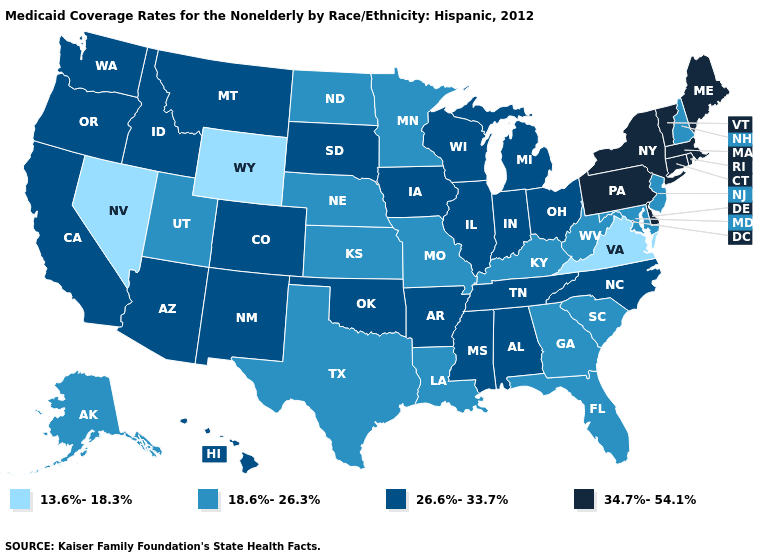What is the highest value in the USA?
Be succinct. 34.7%-54.1%. Which states have the lowest value in the West?
Concise answer only. Nevada, Wyoming. Does Minnesota have the same value as California?
Short answer required. No. Does Vermont have the highest value in the USA?
Write a very short answer. Yes. Is the legend a continuous bar?
Write a very short answer. No. Does Idaho have the same value as Colorado?
Be succinct. Yes. Name the states that have a value in the range 18.6%-26.3%?
Keep it brief. Alaska, Florida, Georgia, Kansas, Kentucky, Louisiana, Maryland, Minnesota, Missouri, Nebraska, New Hampshire, New Jersey, North Dakota, South Carolina, Texas, Utah, West Virginia. Name the states that have a value in the range 26.6%-33.7%?
Be succinct. Alabama, Arizona, Arkansas, California, Colorado, Hawaii, Idaho, Illinois, Indiana, Iowa, Michigan, Mississippi, Montana, New Mexico, North Carolina, Ohio, Oklahoma, Oregon, South Dakota, Tennessee, Washington, Wisconsin. What is the highest value in the West ?
Quick response, please. 26.6%-33.7%. Name the states that have a value in the range 26.6%-33.7%?
Keep it brief. Alabama, Arizona, Arkansas, California, Colorado, Hawaii, Idaho, Illinois, Indiana, Iowa, Michigan, Mississippi, Montana, New Mexico, North Carolina, Ohio, Oklahoma, Oregon, South Dakota, Tennessee, Washington, Wisconsin. What is the highest value in the USA?
Quick response, please. 34.7%-54.1%. What is the highest value in the MidWest ?
Concise answer only. 26.6%-33.7%. Name the states that have a value in the range 18.6%-26.3%?
Keep it brief. Alaska, Florida, Georgia, Kansas, Kentucky, Louisiana, Maryland, Minnesota, Missouri, Nebraska, New Hampshire, New Jersey, North Dakota, South Carolina, Texas, Utah, West Virginia. Name the states that have a value in the range 26.6%-33.7%?
Short answer required. Alabama, Arizona, Arkansas, California, Colorado, Hawaii, Idaho, Illinois, Indiana, Iowa, Michigan, Mississippi, Montana, New Mexico, North Carolina, Ohio, Oklahoma, Oregon, South Dakota, Tennessee, Washington, Wisconsin. What is the lowest value in states that border South Carolina?
Keep it brief. 18.6%-26.3%. 